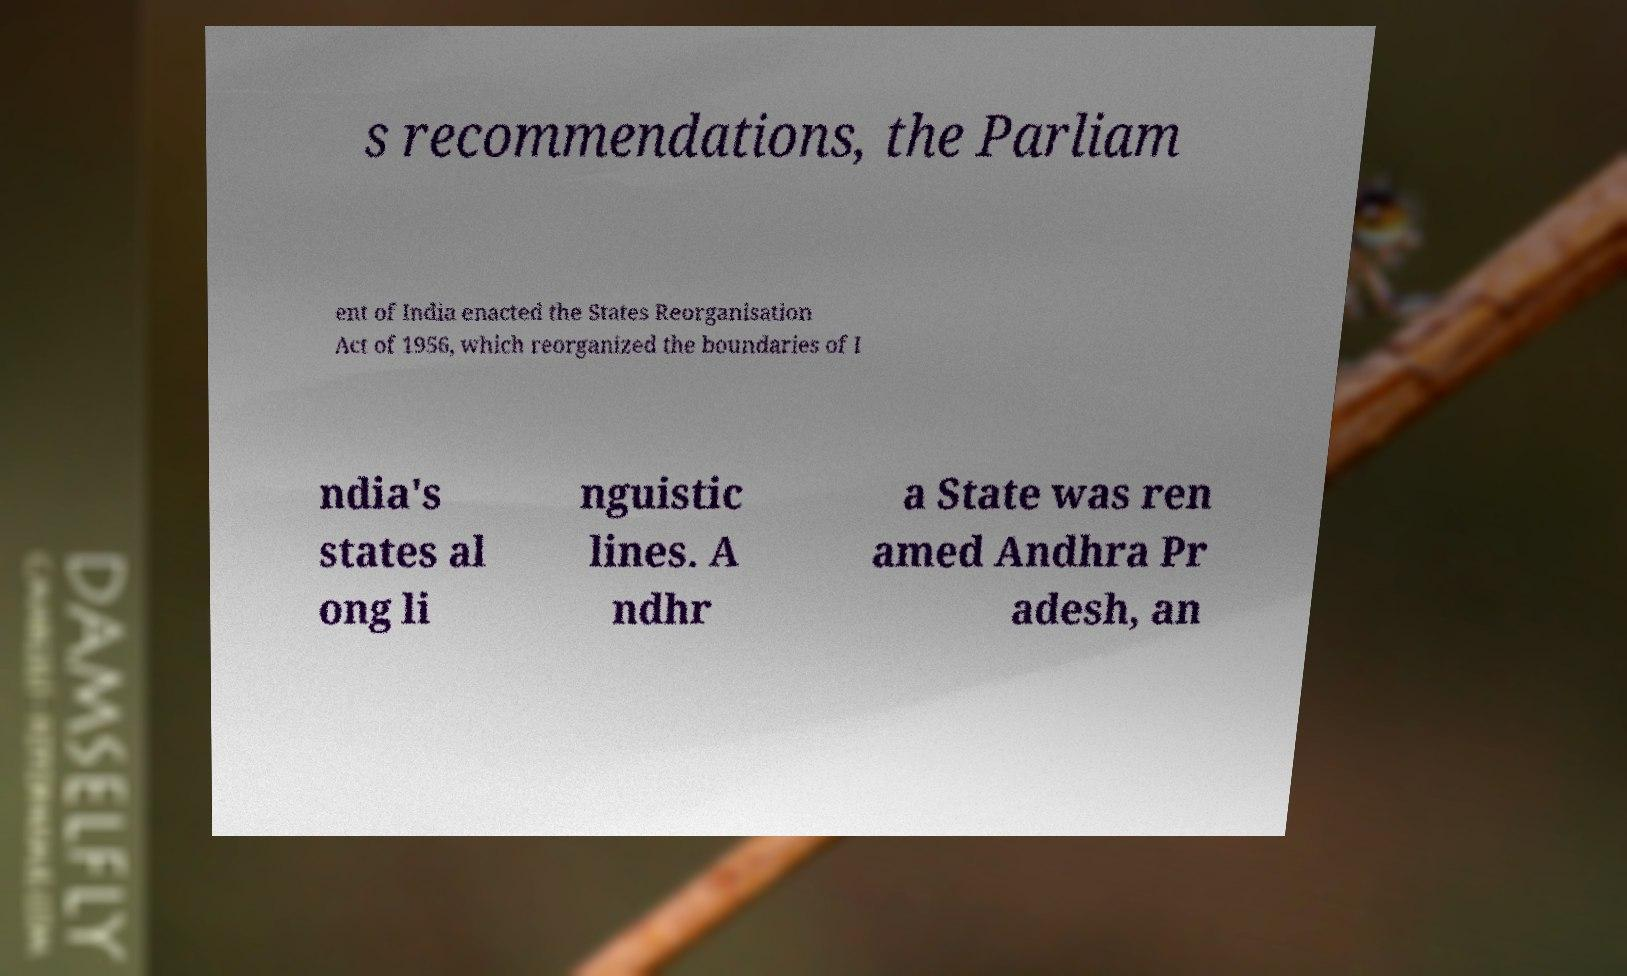Please identify and transcribe the text found in this image. s recommendations, the Parliam ent of India enacted the States Reorganisation Act of 1956, which reorganized the boundaries of I ndia's states al ong li nguistic lines. A ndhr a State was ren amed Andhra Pr adesh, an 